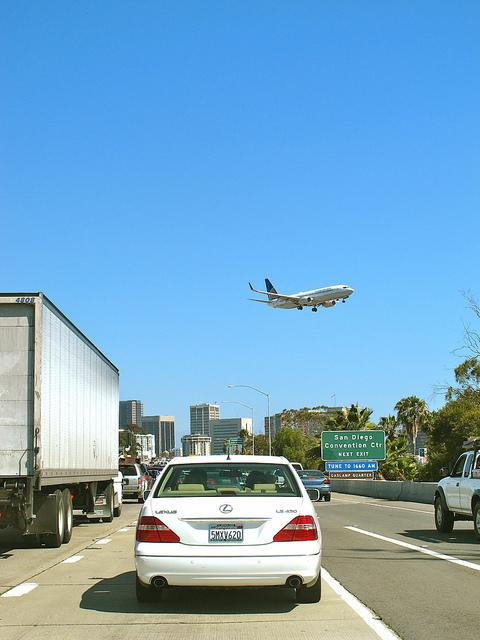This is most likely a scene from which major California city? san diego 